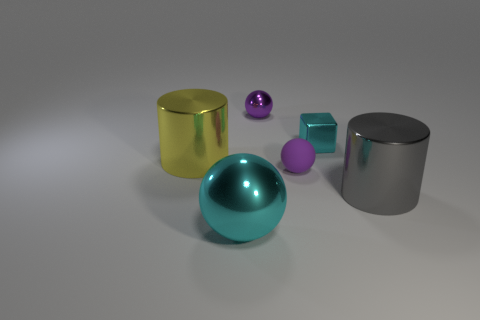Add 2 cyan balls. How many objects exist? 8 Subtract all large red rubber blocks. Subtract all spheres. How many objects are left? 3 Add 2 rubber spheres. How many rubber spheres are left? 3 Add 6 tiny balls. How many tiny balls exist? 8 Subtract 0 blue cubes. How many objects are left? 6 Subtract all cylinders. How many objects are left? 4 